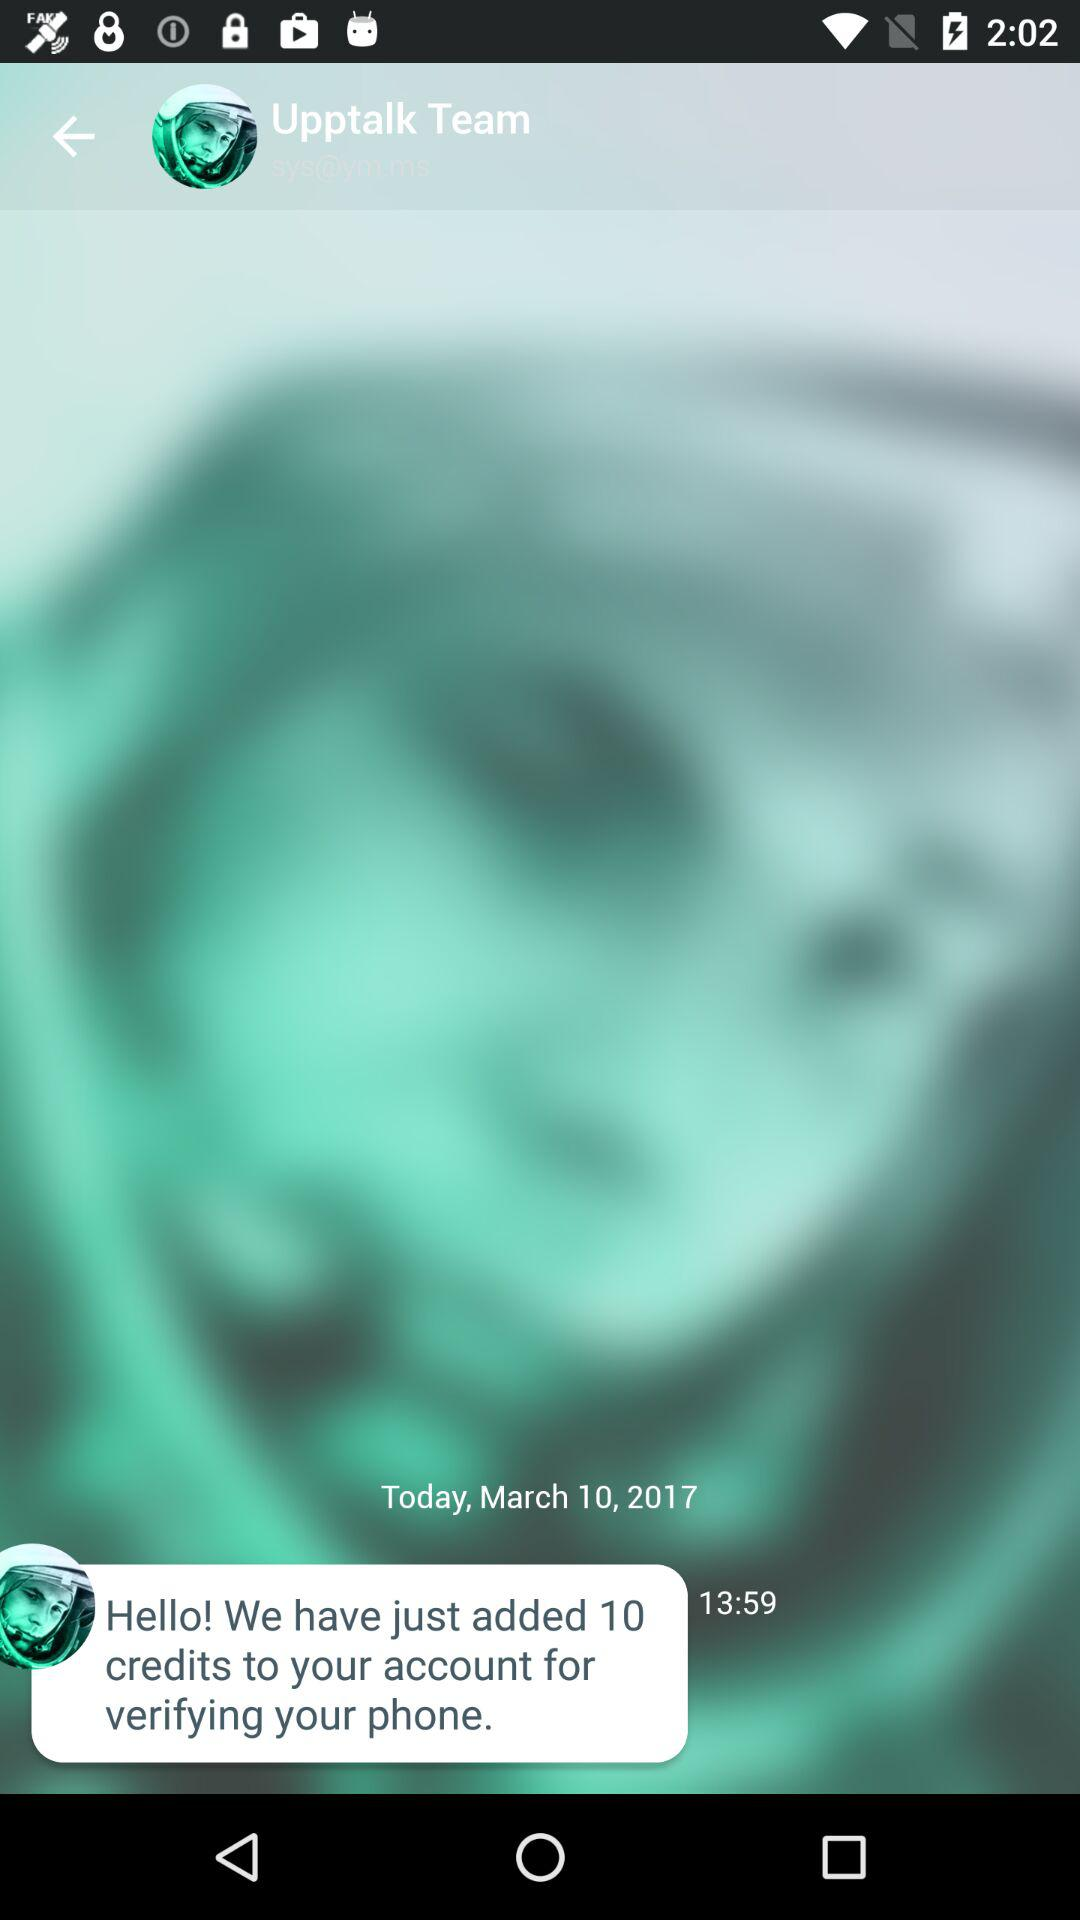How many credits were added to the account?
Answer the question using a single word or phrase. 10 